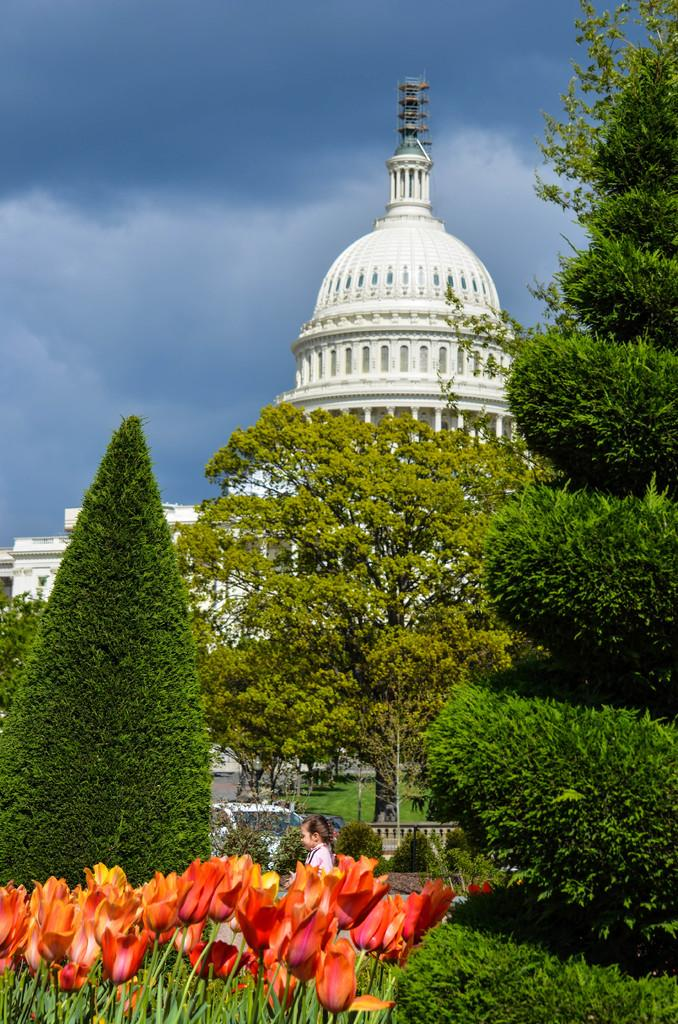What can be seen in the sky in the image? The sky with clouds is visible in the image. What type of structure is present in the image? There is a building in the image, and a dome is also present. What type of vegetation can be seen in the image? Trees, plants, and flowers are visible in the image. What mode of transportation is present in the image? There is a car in the image. Who or what else is present in the image? A kid is present in the image. What type of toothpaste is the kid using in the image? There is no toothpaste present in the image; the kid is not engaged in any activity involving toothpaste. 